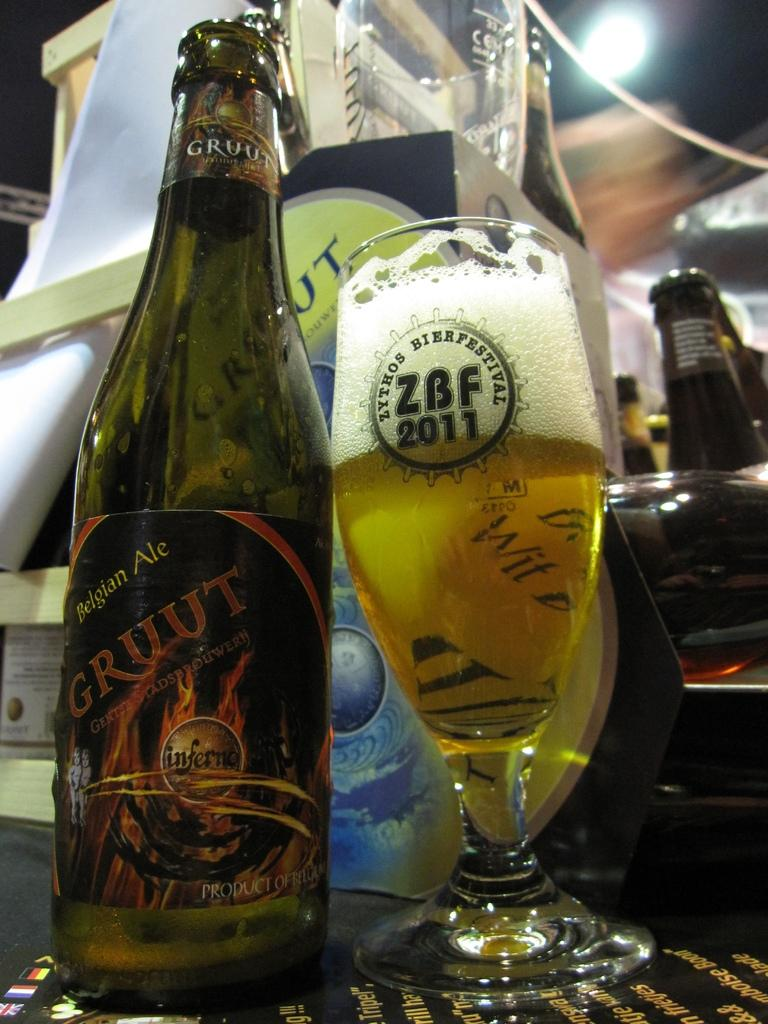What type of beverage container is present in the image? There is a wine bottle in the image. What other item related to wine can be seen in the image? There is a wine glass in the image. How much wine is visible in the image? Wine is filled in the wine glass. What type of engine is visible in the image? There is no engine present in the image; it features a wine bottle and a wine glass. How does the wine provide support to the glass in the image? The wine does not provide support to the glass; it is contained within the glass. 